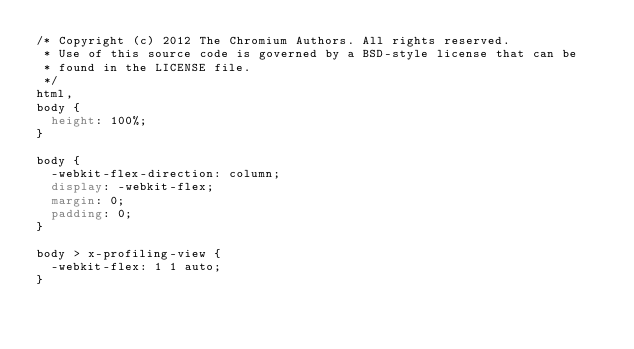<code> <loc_0><loc_0><loc_500><loc_500><_CSS_>/* Copyright (c) 2012 The Chromium Authors. All rights reserved.
 * Use of this source code is governed by a BSD-style license that can be
 * found in the LICENSE file.
 */
html,
body {
  height: 100%;
}

body {
  -webkit-flex-direction: column;
  display: -webkit-flex;
  margin: 0;
  padding: 0;
}

body > x-profiling-view {
  -webkit-flex: 1 1 auto;
}

</code> 